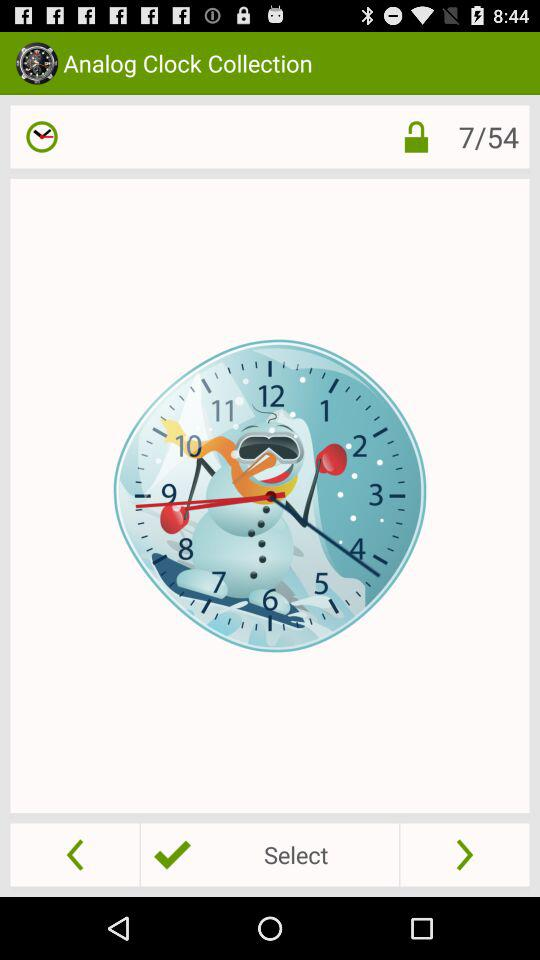What does image number 8 look like?
When the provided information is insufficient, respond with <no answer>. <no answer> 